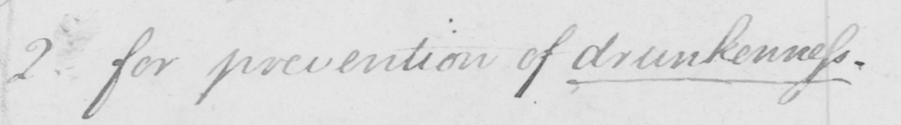What text is written in this handwritten line? 2 . for prevention of drunkenness . 